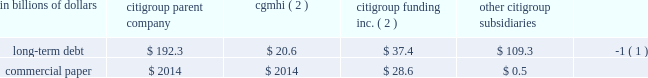Sources of liquidity primary sources of liquidity for citigroup and its principal subsidiaries include : 2022 deposits ; 2022 collateralized financing transactions ; 2022 senior and subordinated debt ; 2022 commercial paper ; 2022 trust preferred and preferred securities ; and 2022 purchased/wholesale funds .
Citigroup 2019s funding sources are diversified across funding types and geography , a benefit of its global franchise .
Funding for citigroup and its major operating subsidiaries includes a geographically diverse retail and corporate deposit base of $ 774.2 billion .
These deposits are diversified across products and regions , with approximately two-thirds of them outside of the u.s .
This diversification provides the company with an important , stable and low-cost source of funding .
A significant portion of these deposits has been , and is expected to be , long-term and stable , and are considered to be core .
There are qualitative as well as quantitative assessments that determine the company 2019s calculation of core deposits .
The first step in this process is a qualitative assessment of the deposits .
For example , as a result of the company 2019s qualitative analysis certain deposits with wholesale funding characteristics are excluded from consideration as core .
Deposits that qualify under the company 2019s qualitative assessments are then subjected to quantitative analysis .
Excluding the impact of changes in foreign exchange rates and the sale of our retail banking operations in germany during the year ending december 31 , 2008 , the company 2019s deposit base remained stable .
On a volume basis , deposit increases were noted in transaction services , u.s .
Retail banking and smith barney .
This was partially offset by the company 2019s decision to reduce deposits considered wholesale funding , consistent with the company 2019s de-leveraging efforts , and declines in international consumer banking and the private bank .
Citigroup and its subsidiaries have historically had a significant presence in the global capital markets .
The company 2019s capital markets funding activities have been primarily undertaken by two legal entities : ( i ) citigroup inc. , which issues long-term debt , medium-term notes , trust preferred securities , and preferred and common stock ; and ( ii ) citigroup funding inc .
( cfi ) , a first-tier subsidiary of citigroup , which issues commercial paper , medium-term notes and structured equity-linked and credit-linked notes , all of which are guaranteed by citigroup .
Other significant elements of long- term debt on the consolidated balance sheet include collateralized advances from the federal home loan bank system , long-term debt related to the consolidation of icg 2019s structured investment vehicles , asset-backed outstandings , and certain borrowings of foreign subsidiaries .
Each of citigroup 2019s major operating subsidiaries finances its operations on a basis consistent with its capitalization , regulatory structure and the environment in which it operates .
Particular attention is paid to those businesses that for tax , sovereign risk , or regulatory reasons cannot be freely and readily funded in the international markets .
Citigroup 2019s borrowings have historically been diversified by geography , investor , instrument and currency .
Decisions regarding the ultimate currency and interest rate profile of liquidity generated through these borrowings can be separated from the actual issuance through the use of derivative instruments .
Citigroup is a provider of liquidity facilities to the commercial paper programs of the two primary credit card securitization trusts with which it transacts .
Citigroup may also provide other types of support to the trusts .
As a result of the recent economic downturn , its impact on the cashflows of the trusts , and in response to credit rating agency reviews of the trusts , the company increased the credit enhancement in the omni trust , and plans to provide additional enhancement to the master trust ( see note 23 to consolidated financial statements on page 175 for a further discussion ) .
This support preserves investor sponsorship of our card securitization franchise , an important source of liquidity .
Banking subsidiaries there are various legal limitations on the ability of citigroup 2019s subsidiary depository institutions to extend credit , pay dividends or otherwise supply funds to citigroup and its non-bank subsidiaries .
The approval of the office of the comptroller of the currency , in the case of national banks , or the office of thrift supervision , in the case of federal savings banks , is required if total dividends declared in any calendar year exceed amounts specified by the applicable agency 2019s regulations .
State-chartered depository institutions are subject to dividend limitations imposed by applicable state law .
In determining the declaration of dividends , each depository institution must also consider its effect on applicable risk-based capital and leverage ratio requirements , as well as policy statements of the federal regulatory agencies that indicate that banking organizations should generally pay dividends out of current operating earnings .
Non-banking subsidiaries citigroup also receives dividends from its non-bank subsidiaries .
These non-bank subsidiaries are generally not subject to regulatory restrictions on dividends .
However , as discussed in 201ccapital resources and liquidity 201d on page 94 , the ability of cgmhi to declare dividends can be restricted by capital considerations of its broker-dealer subsidiaries .
Cgmhi 2019s consolidated balance sheet is liquid , with the vast majority of its assets consisting of marketable securities and collateralized short-term financing agreements arising from securities transactions .
Cgmhi monitors and evaluates the adequacy of its capital and borrowing base on a daily basis to maintain liquidity and to ensure that its capital base supports the regulatory capital requirements of its subsidiaries .
Some of citigroup 2019s non-bank subsidiaries , including cgmhi , have credit facilities with citigroup 2019s subsidiary depository institutions , including citibank , n.a .
Borrowings under these facilities must be secured in accordance with section 23a of the federal reserve act .
There are various legal restrictions on the extent to which a bank holding company and certain of its non-bank subsidiaries can borrow or obtain credit from citigroup 2019s subsidiary depository institutions or engage in certain other transactions with them .
In general , these restrictions require that transactions be on arm 2019s length terms and be secured by designated amounts of specified collateral .
See note 20 to the consolidated financial statements on page 169 .
At december 31 , 2008 , long-term debt and commercial paper outstanding for citigroup , cgmhi , cfi and citigroup 2019s subsidiaries were as follows : in billions of dollars citigroup parent company cgmhi ( 2 ) citigroup funding inc .
( 2 ) citigroup subsidiaries long-term debt $ 192.3 $ 20.6 $ 37.4 $ 109.3 ( 1 ) .
( 1 ) at december 31 , 2008 , approximately $ 67.4 billion relates to collateralized advances from the federal home loan bank .
( 2 ) citigroup inc .
Guarantees all of cfi 2019s debt and cgmhi 2019s publicly issued securities. .
What is the total long-term debt in billions of dollars for citigroup , cgmhi , cfi and citigroup 2019s subsidiaries at december 31 , 2008? 
Computations: (((192.3 + 20.6) + 37.4) + 109.3)
Answer: 359.6. 